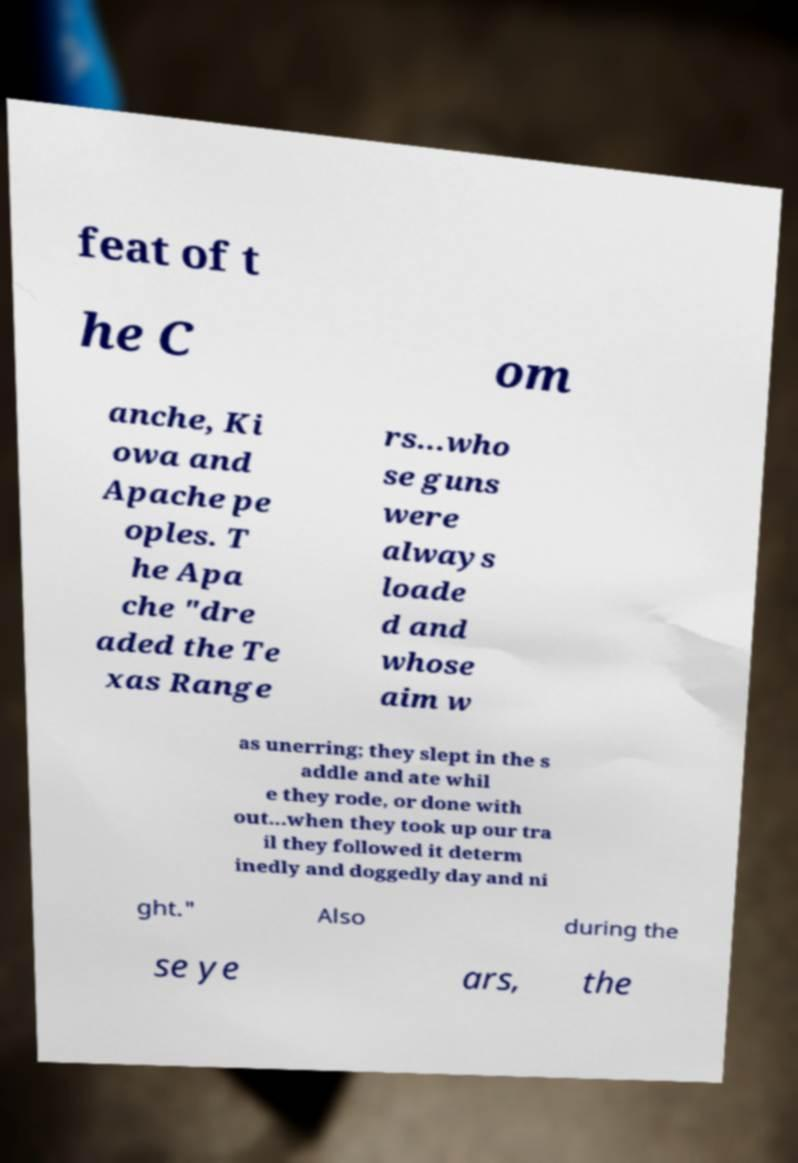Could you extract and type out the text from this image? feat of t he C om anche, Ki owa and Apache pe oples. T he Apa che "dre aded the Te xas Range rs...who se guns were always loade d and whose aim w as unerring; they slept in the s addle and ate whil e they rode, or done with out...when they took up our tra il they followed it determ inedly and doggedly day and ni ght." Also during the se ye ars, the 